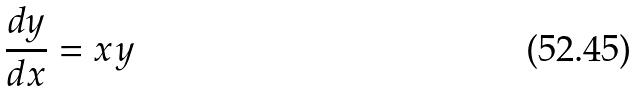Convert formula to latex. <formula><loc_0><loc_0><loc_500><loc_500>\frac { d y } { d x } = x y</formula> 